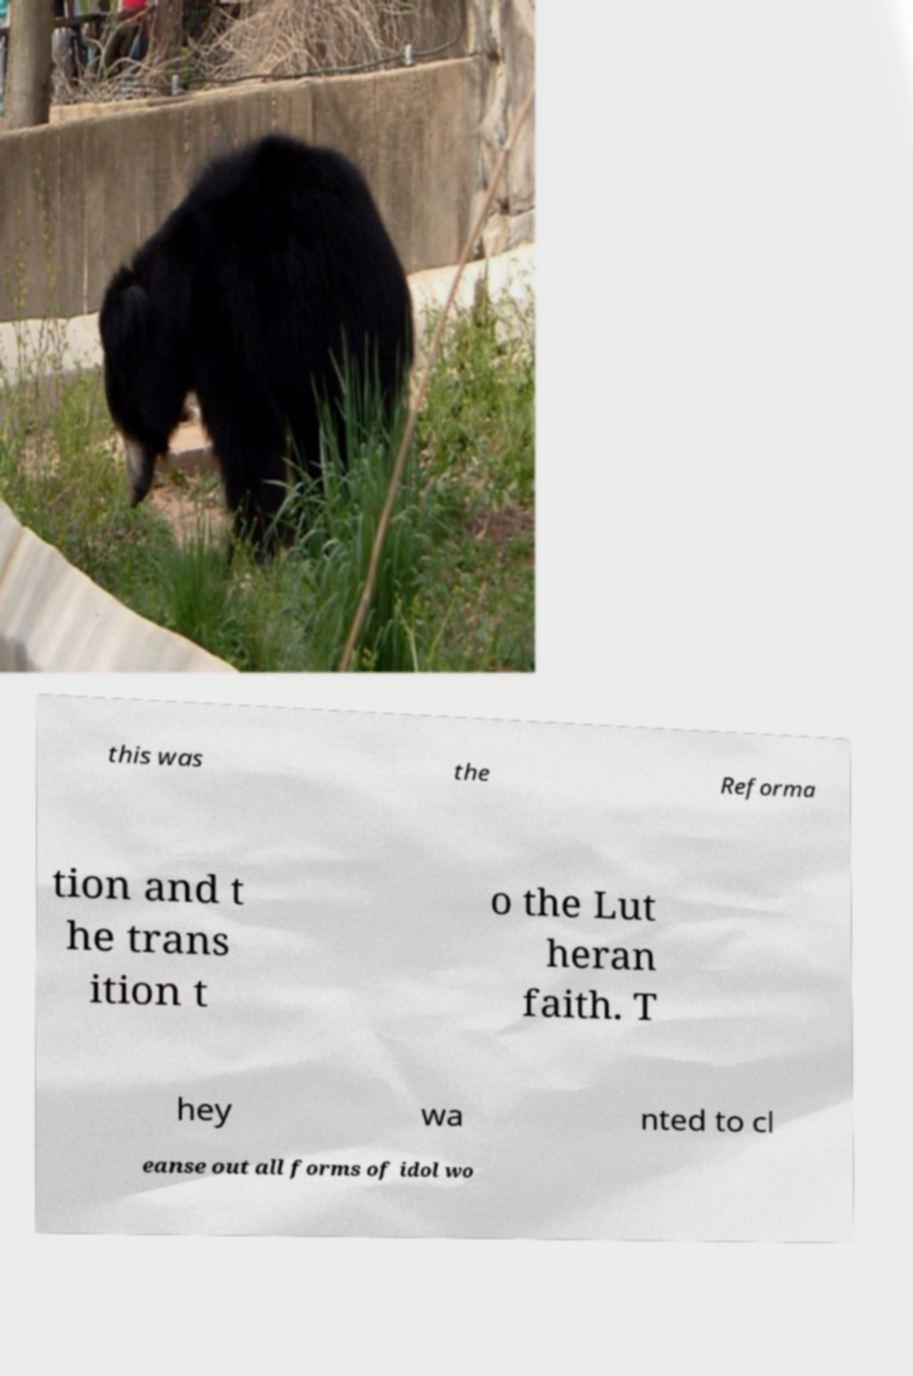Please read and relay the text visible in this image. What does it say? this was the Reforma tion and t he trans ition t o the Lut heran faith. T hey wa nted to cl eanse out all forms of idol wo 